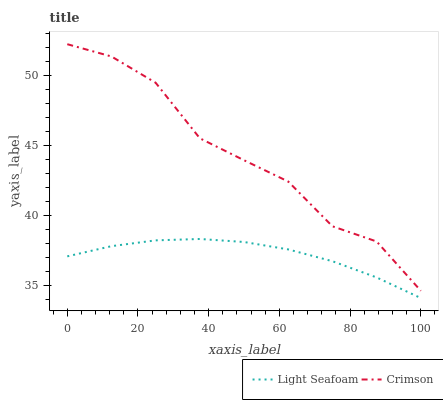Does Light Seafoam have the minimum area under the curve?
Answer yes or no. Yes. Does Crimson have the maximum area under the curve?
Answer yes or no. Yes. Does Light Seafoam have the maximum area under the curve?
Answer yes or no. No. Is Light Seafoam the smoothest?
Answer yes or no. Yes. Is Crimson the roughest?
Answer yes or no. Yes. Is Light Seafoam the roughest?
Answer yes or no. No. Does Light Seafoam have the lowest value?
Answer yes or no. Yes. Does Crimson have the highest value?
Answer yes or no. Yes. Does Light Seafoam have the highest value?
Answer yes or no. No. Is Light Seafoam less than Crimson?
Answer yes or no. Yes. Is Crimson greater than Light Seafoam?
Answer yes or no. Yes. Does Light Seafoam intersect Crimson?
Answer yes or no. No. 